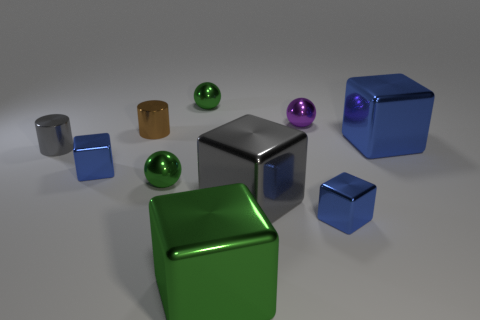How many blue blocks must be subtracted to get 1 blue blocks? 2 Subtract all blue balls. How many blue cubes are left? 3 Subtract all green blocks. How many blocks are left? 4 Subtract all big green metal blocks. How many blocks are left? 4 Subtract all brown cubes. Subtract all blue spheres. How many cubes are left? 5 Subtract all cylinders. How many objects are left? 8 Subtract all tiny cubes. Subtract all purple things. How many objects are left? 7 Add 9 brown objects. How many brown objects are left? 10 Add 1 tiny matte cylinders. How many tiny matte cylinders exist? 1 Subtract 0 cyan cubes. How many objects are left? 10 